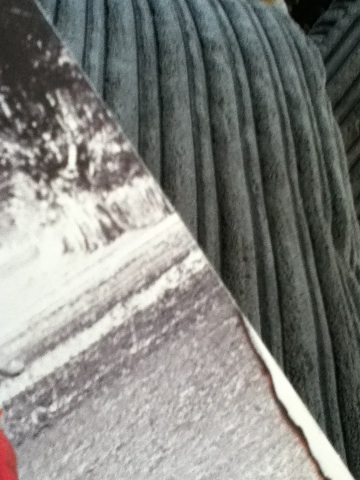Is there any visible text or imagery that hints at the genre of the book? The photo does not provide a clear view of any text or imagery that could confidently hint at the book's genre. The visible elements are limited and ambiguous, and without more information or a more revealing angle, it remains speculative. Generally, certain design elements like fonts, colors, and images are indicative of genre—bold lettering or darker colors may suggest mystery or thriller, while light and airy designs might imply romance or contemporary fiction. A clearer image would be needed for a more accurate assessment. 